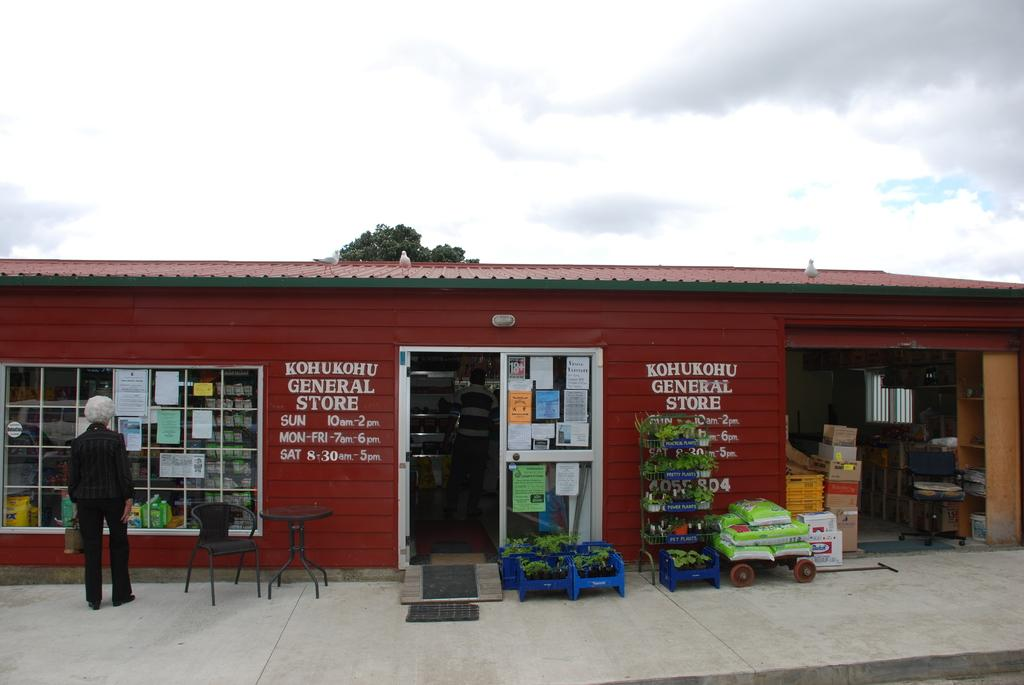<image>
Describe the image concisely. The Kohukohu General Store has some plants for sale out front. 